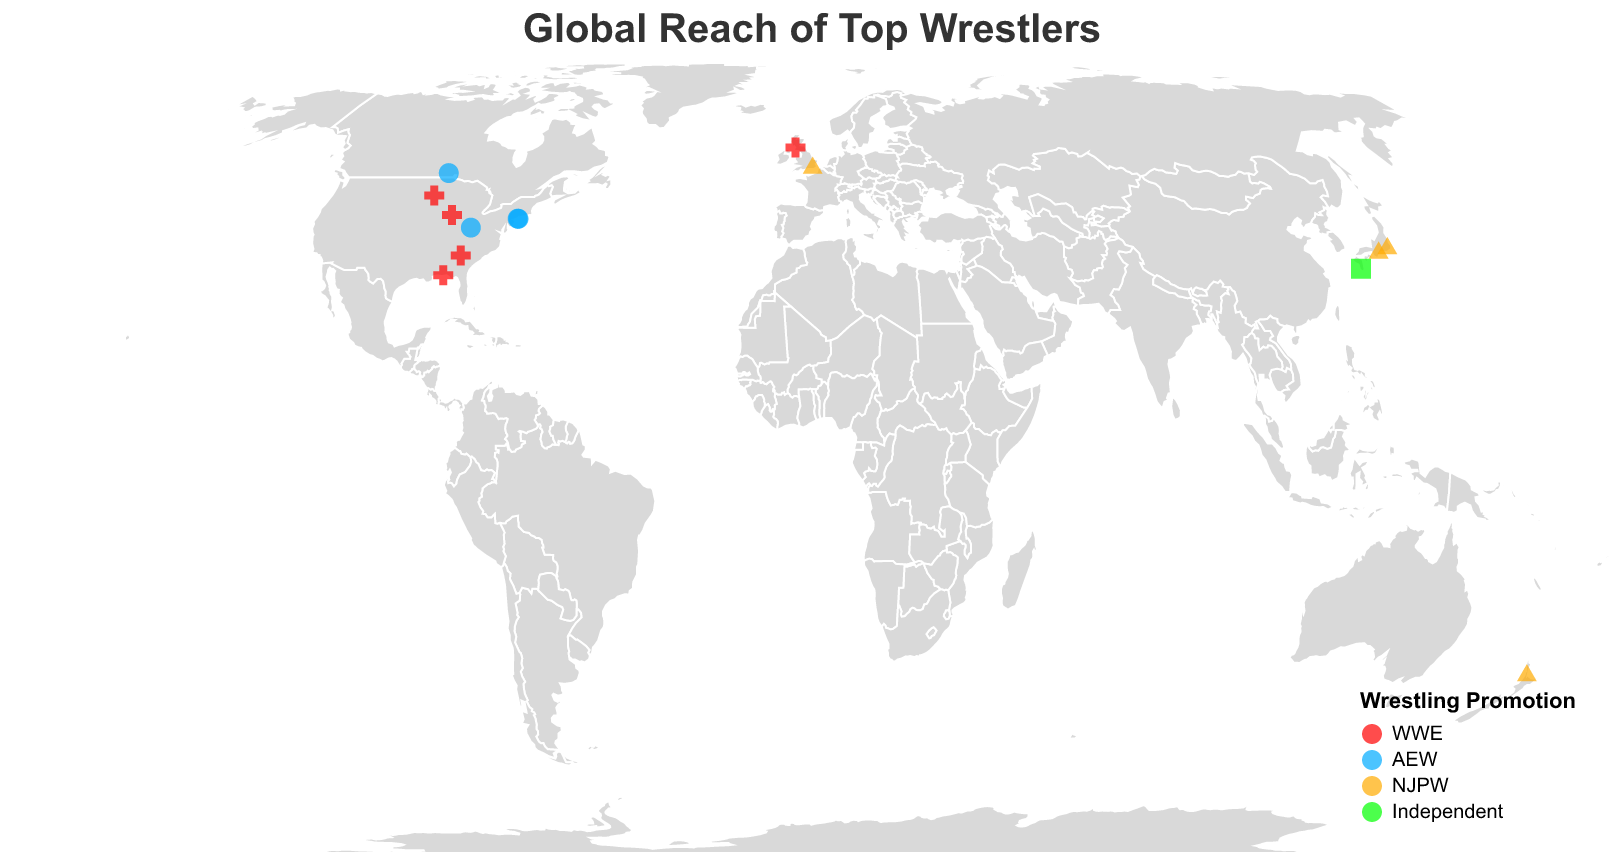What is the title of the map? The title appears at the top center of the map and reads "Global Reach of Top Wrestlers."
Answer: Global Reach of Top Wrestlers How many wrestlers are from WWE? By examining the color assigned to WWE (red) on the map and identifying all red points, we find 6 wrestlers from the WWE.
Answer: 6 Which promotion has the most wrestlers from the United States? By looking at the points located in the United States and identifying their promotions, we see more points corresponding to WWE (red) than any other promotion in the US.
Answer: WWE What is the hometown of Kenny Omega? Hovering over or locating the text near the point linked to Kenny Omega (blue point for AEW) reveals Winnipeg, MB, Canada as his hometown.
Answer: Winnipeg MB Canada Which wrestler hails from the southernmost latitude? By identifying the point with the most negative latitude value on the map, we see that Jay White from Auckland, New Zealand, is the southernmost wrestler.
Answer: Jay White How many different countries do the wrestlers on the map come from? Counting the number of unique countries for the wrestlers' hometowns: USA, Canada, Japan, England, New Zealand, Scotland sums up to 6 countries.
Answer: 6 Which wrestler's hometown is the farthest west in the USA? Looking at the points on the westernmost side of the USA map, Roman Reigns' Pensacola, FL with a longitude of -87.2169 is the farthest west amongst the U.S. wrestlers.
Answer: Roman Reigns How many wrestlers are there from Japan, and which promotions do they represent? By identifying the locations within Japan and checking their promotions, there are three wrestlers from Japan: Kazuchika Okada (NJPW), Tetsuya Naito (NJPW), and Kota Ibushi (Independent).
Answer: 3; NJPW and Independent Which wrestlers share the closest hometown locations? By comparing the distances between points, MJF (Plainview, NY) and Chris Jericho (Manhasset, NY) are the closest geographically.
Answer: MJF and Chris Jericho 